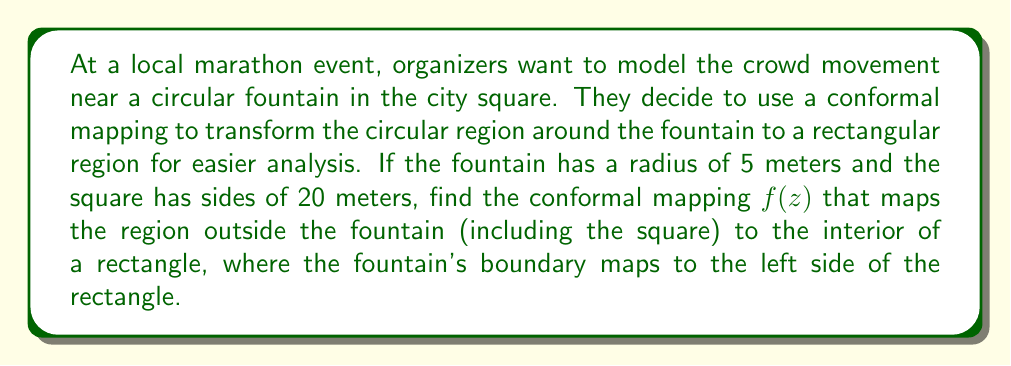Help me with this question. To solve this problem, we'll use the following steps:

1) The conformal mapping that transforms the exterior of a circle to the interior of a rectangle is a composition of two functions:
   a) The logarithmic function
   b) A linear transformation

2) First, we need to use the logarithmic function to map the exterior of the circle to a semi-infinite strip:

   $w = \log(z/R)$

   where $R$ is the radius of the circle (fountain).

3) This maps the circle $|z| = R$ to the imaginary axis, and the region outside the circle to the right half-plane.

4) Now, we need to map this semi-infinite strip to a rectangle. We can do this with a linear transformation:

   $f(w) = aw + b$

   where $a$ and $b$ are complex constants we need to determine.

5) The full conformal mapping will be:

   $f(z) = a\log(z/R) + b$

6) To determine $a$ and $b$, we need to consider the boundary conditions:
   - The circle $|z| = R$ should map to the left side of the rectangle
   - The square boundary should map to the other three sides of the rectangle

7) The circle maps to the imaginary axis in the $w$-plane: $w = i\theta$, where $-\pi < \theta < \pi$

8) The square has sides of 20 meters, so its vertices are at $z = \pm 10 \pm 10i$

9) These vertices should map to the corners of the rectangle. Let's say the rectangle has width 1 and height $h$ in the $f$-plane.

10) This gives us the equations:

    $a\log((10+10i)/5) + b = 1 + ih$
    $a\log((10-10i)/5) + b = 1$

11) Subtracting these equations:

    $a[\log((10+10i)/5) - \log((10-10i)/5)] = ih$

12) The left side simplifies to $a\pi i = ih$, so $a = h/\pi$

13) Substituting back into one of the equations from step 10:

    $(h/\pi)\log(2+2i) + b = 1$

14) Solving for $b$:

    $b = 1 - (h/\pi)\log(2+2i)$

Therefore, the conformal mapping is:

$$f(z) = \frac{h}{\pi}\log(z/5) + [1 - \frac{h}{\pi}\log(2+2i)]$$

where $h$ is the height of the rectangle in the $f$-plane.
Answer: The conformal mapping is:

$$f(z) = \frac{h}{\pi}\log(z/5) + [1 - \frac{h}{\pi}\log(2+2i)]$$

where $h$ is the height of the resulting rectangle. 